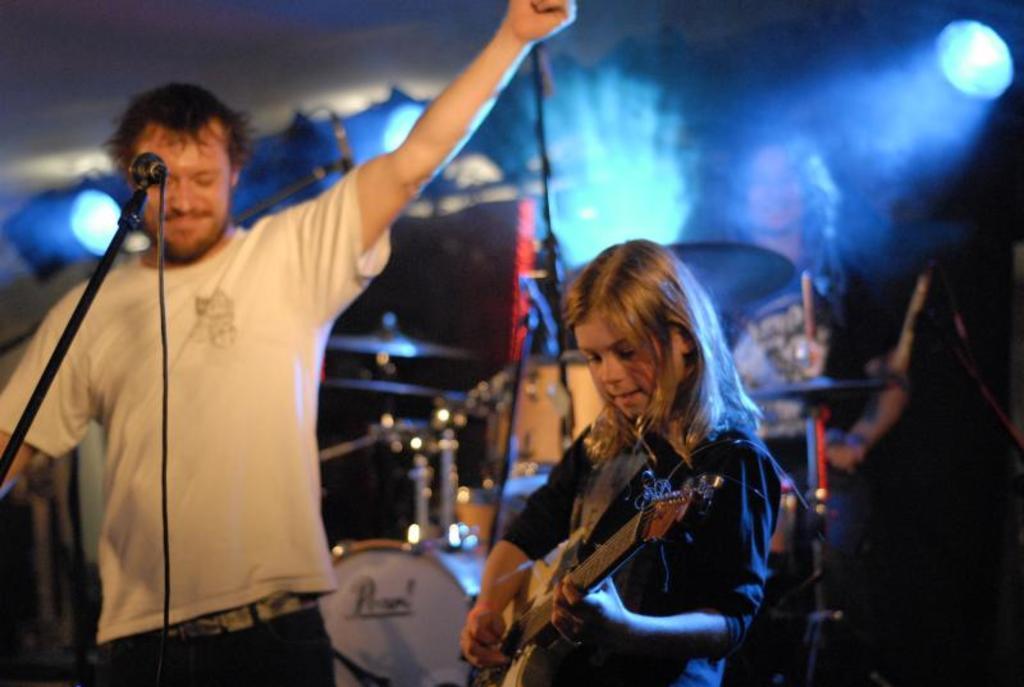In one or two sentences, can you explain what this image depicts? In this picture there is a man who is standing at the left side of the image and he is raising his hand, there is a girl who is standing at the right side of the image, who is playing the guitar and there are drum set behind them and a spotlight above the are of the image. 